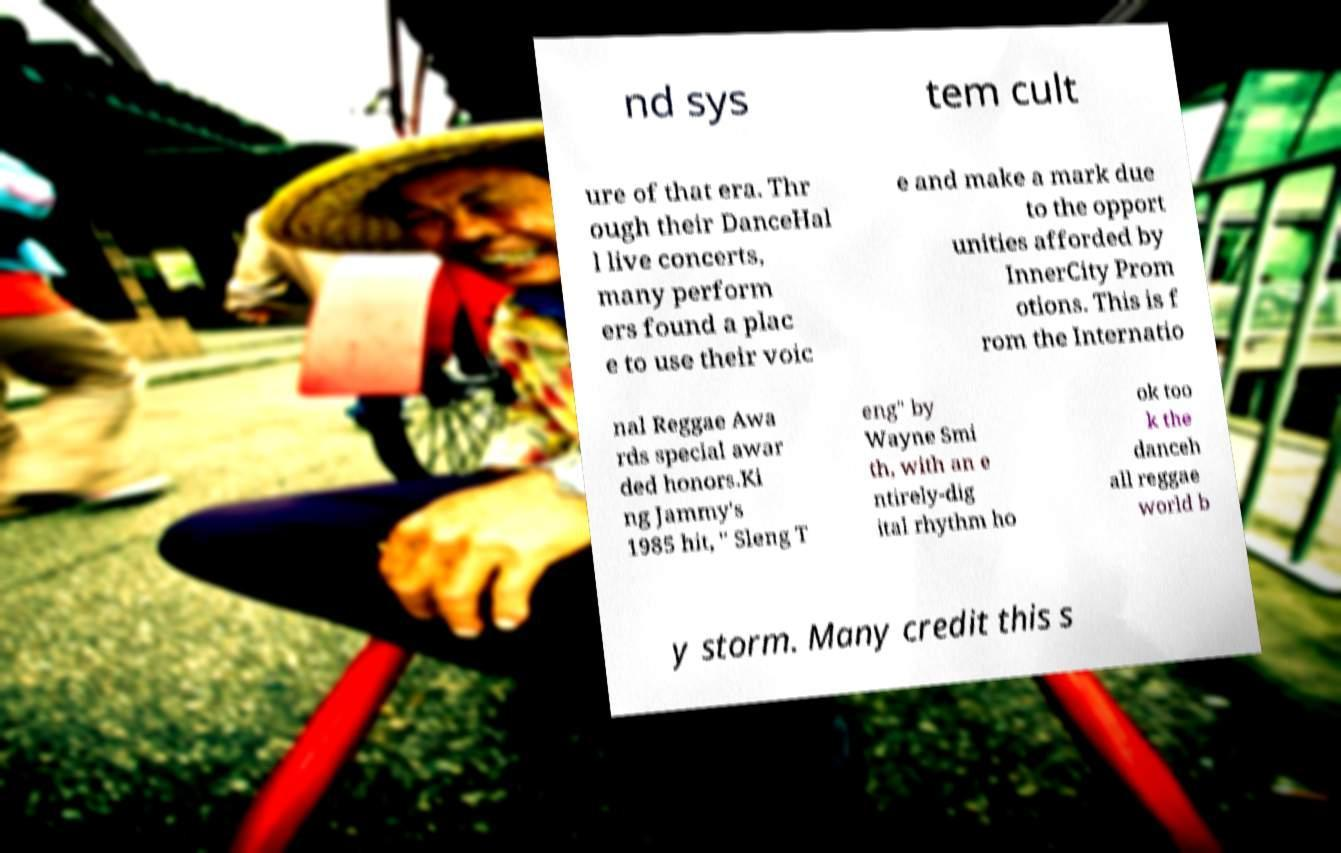Please identify and transcribe the text found in this image. nd sys tem cult ure of that era. Thr ough their DanceHal l live concerts, many perform ers found a plac e to use their voic e and make a mark due to the opport unities afforded by InnerCity Prom otions. This is f rom the Internatio nal Reggae Awa rds special awar ded honors.Ki ng Jammy's 1985 hit, " Sleng T eng" by Wayne Smi th, with an e ntirely-dig ital rhythm ho ok too k the danceh all reggae world b y storm. Many credit this s 